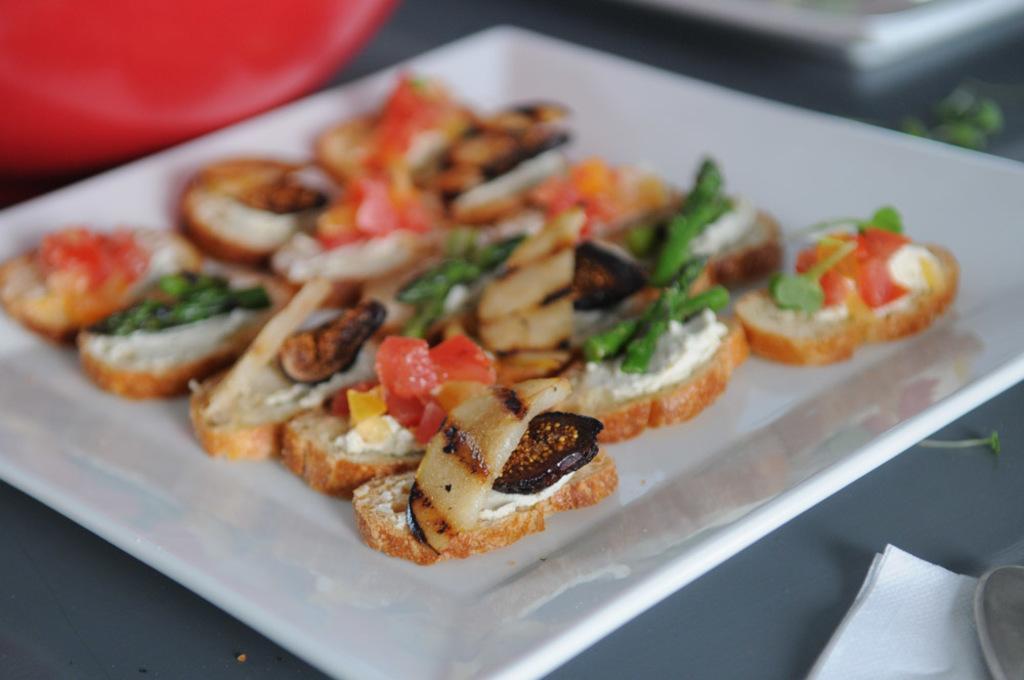Can you describe this image briefly? Here I can see a table on which a saucer, a tissue paper and some other objects are placed. On the sauce I can see some food items. 